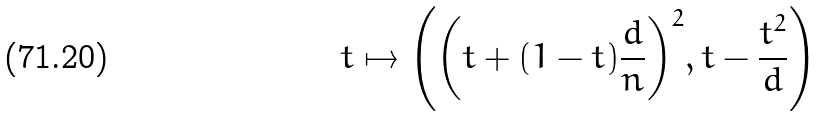Convert formula to latex. <formula><loc_0><loc_0><loc_500><loc_500>t \mapsto \left ( { \left ( t + ( 1 - t ) \frac { d } { n } \right ) } ^ { 2 } , t - \frac { t ^ { 2 } } { d } \right )</formula> 